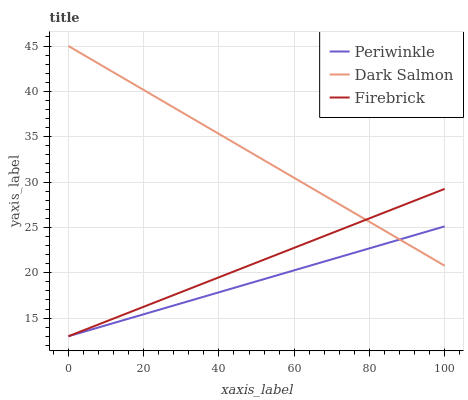Does Periwinkle have the minimum area under the curve?
Answer yes or no. Yes. Does Dark Salmon have the maximum area under the curve?
Answer yes or no. Yes. Does Dark Salmon have the minimum area under the curve?
Answer yes or no. No. Does Periwinkle have the maximum area under the curve?
Answer yes or no. No. Is Firebrick the smoothest?
Answer yes or no. Yes. Is Dark Salmon the roughest?
Answer yes or no. Yes. Is Periwinkle the smoothest?
Answer yes or no. No. Is Periwinkle the roughest?
Answer yes or no. No. Does Firebrick have the lowest value?
Answer yes or no. Yes. Does Dark Salmon have the lowest value?
Answer yes or no. No. Does Dark Salmon have the highest value?
Answer yes or no. Yes. Does Periwinkle have the highest value?
Answer yes or no. No. Does Dark Salmon intersect Periwinkle?
Answer yes or no. Yes. Is Dark Salmon less than Periwinkle?
Answer yes or no. No. Is Dark Salmon greater than Periwinkle?
Answer yes or no. No. 